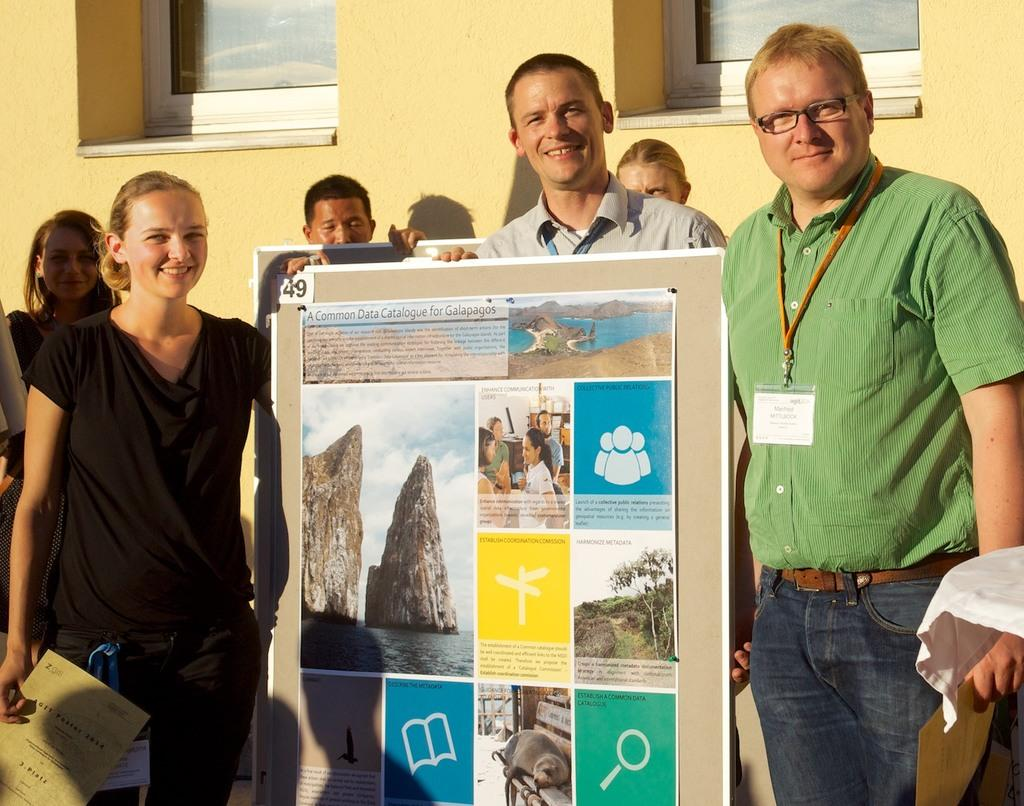What are the people in the image doing? The people in the image are standing and holding boards. What can be seen in the background of the image? There is a wall in the background of the image. What is special about the wall in the background? The wall has glass windows. Can you see any bees buzzing around the people in the image? There are no bees visible in the image. What type of teeth do the people have? There is no information about the people's teeth in the image. 